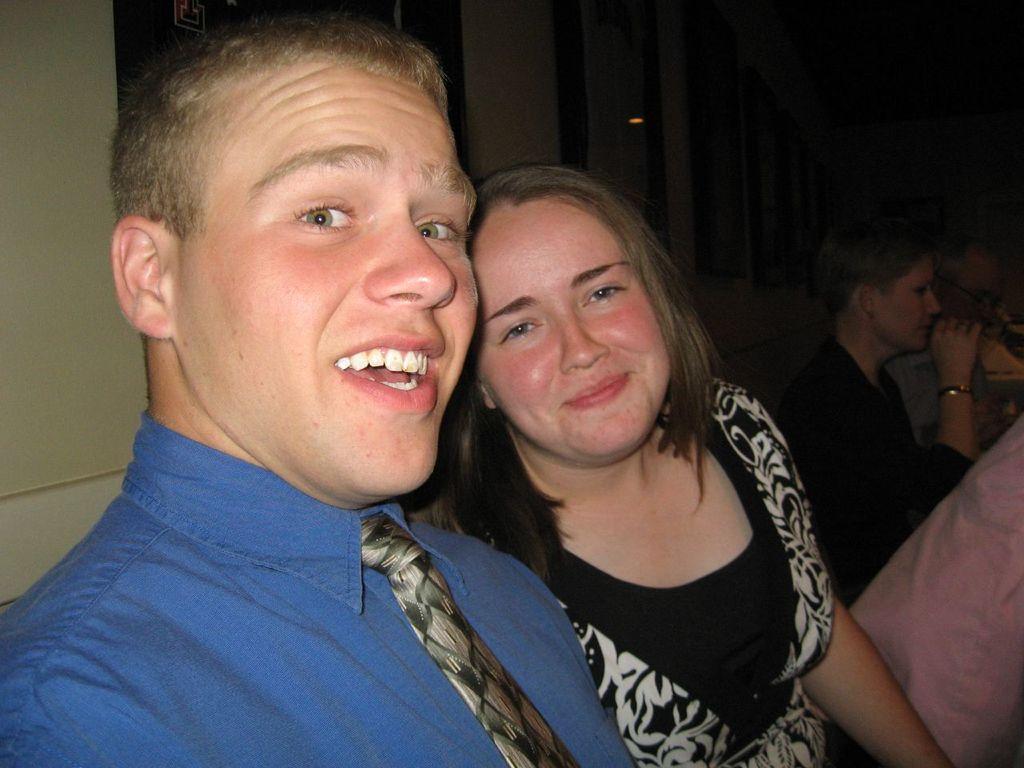Describe this image in one or two sentences. A man is speaking, he wore a blue color shirt, tie. Beside him a woman is there, she is smiling, she wore a black color dress. 